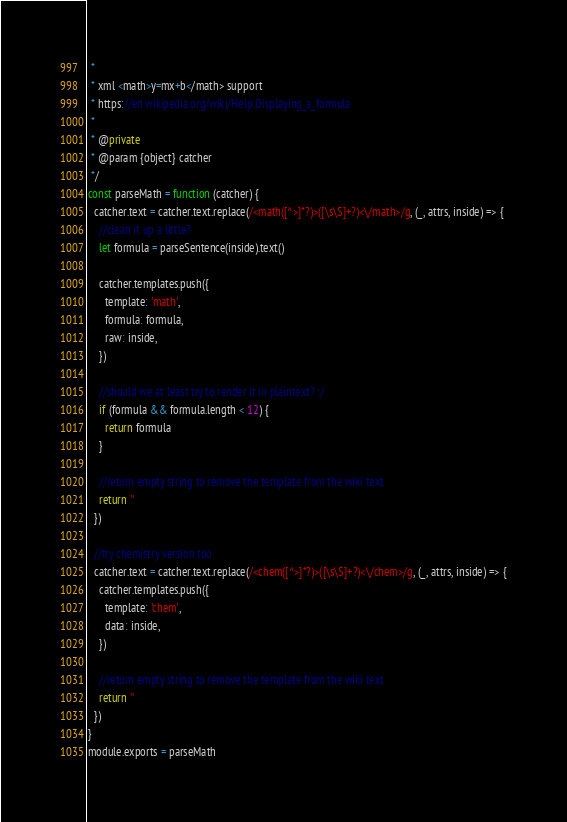<code> <loc_0><loc_0><loc_500><loc_500><_JavaScript_> *
 * xml <math>y=mx+b</math> support
 * https://en.wikipedia.org/wiki/Help:Displaying_a_formula
 *
 * @private
 * @param {object} catcher
 */
const parseMath = function (catcher) {
  catcher.text = catcher.text.replace(/<math([^>]*?)>([\s\S]+?)<\/math>/g, (_, attrs, inside) => {
    //clean it up a little?
    let formula = parseSentence(inside).text()

    catcher.templates.push({
      template: 'math',
      formula: formula,
      raw: inside,
    })

    //should we at least try to render it in plaintext? :/
    if (formula && formula.length < 12) {
      return formula
    }

    //return empty string to remove the template from the wiki text
    return ''
  })

  //try chemistry version too
  catcher.text = catcher.text.replace(/<chem([^>]*?)>([\s\S]+?)<\/chem>/g, (_, attrs, inside) => {
    catcher.templates.push({
      template: 'chem',
      data: inside,
    })

    //return empty string to remove the template from the wiki text
    return ''
  })
}
module.exports = parseMath
</code> 